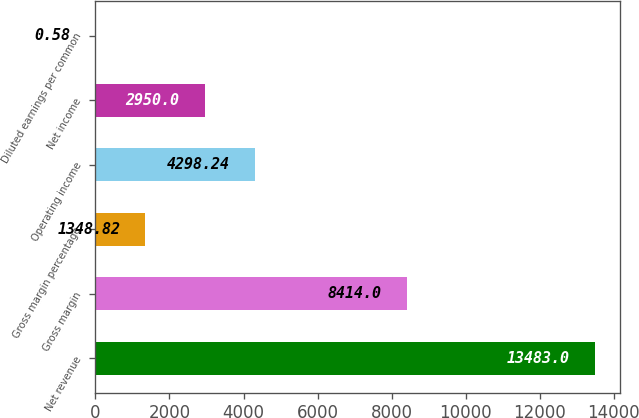Convert chart. <chart><loc_0><loc_0><loc_500><loc_500><bar_chart><fcel>Net revenue<fcel>Gross margin<fcel>Gross margin percentage<fcel>Operating income<fcel>Net income<fcel>Diluted earnings per common<nl><fcel>13483<fcel>8414<fcel>1348.82<fcel>4298.24<fcel>2950<fcel>0.58<nl></chart> 